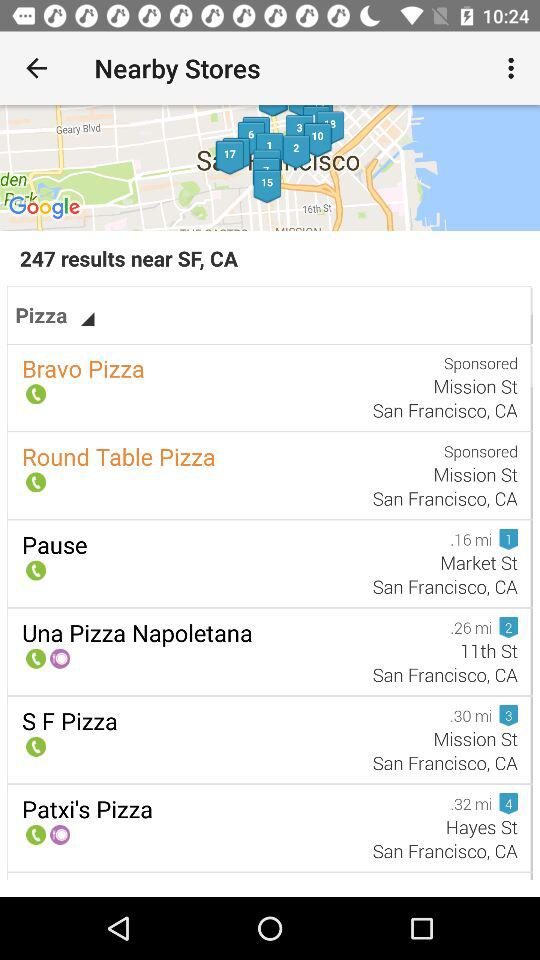How far is the "Pause" from my location? The "Pause" is 0.16 miles away from your location. 